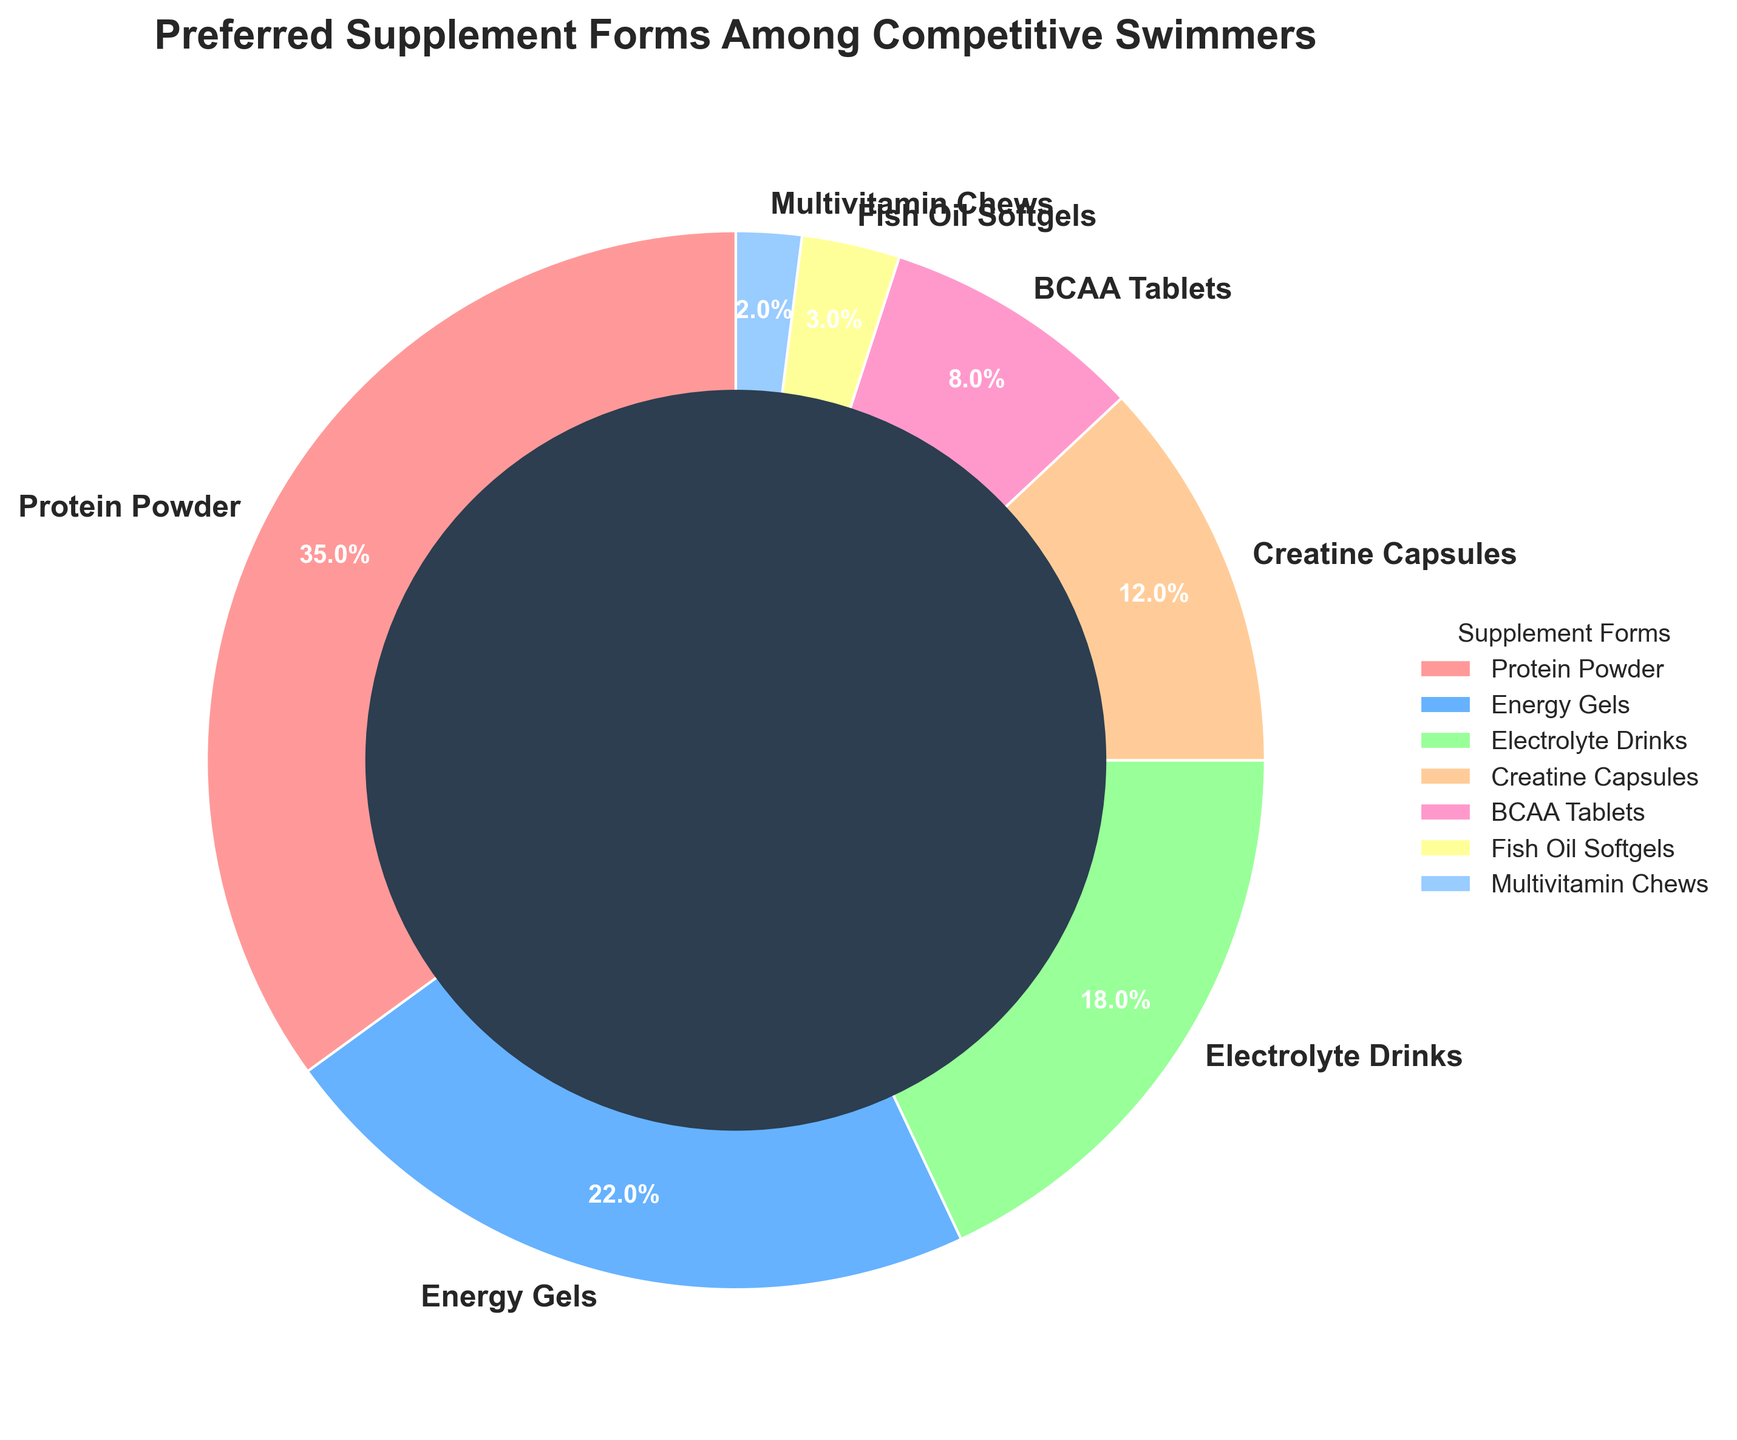What percentage of swimmers prefer Protein Powder and Energy Gels combined? To find the combined percentage for Protein Powder and Energy Gels, add their individual percentages: 35% (Protein Powder) + 22% (Energy Gels) = 57%
Answer: 57% Which supplement form has the lowest preference among competitive swimmers? Look at the pie chart and identify the segment with the smallest percentage. Multivitamin Chews are shown as the smallest segment with 2%
Answer: Multivitamin Chews Is the percentage of swimmers who prefer Electrolyte Drinks more than those who prefer Creatine Capsules and Fish Oil Softgels combined? Sum the percentages of Creatine Capsules and Fish Oil Softgels: 12% + 3% = 15%. Compare this with the percentage of Electrolyte Drinks, which is 18%. Since 18% > 15%, the answer is yes
Answer: Yes By how much does the preference for Protein Powder exceed the preference for BCAA Tablets? Subtract the percentage of BCAA Tablets from that of Protein Powder: 35% - 8% = 27%
Answer: 27% Which two supplement forms have a combined preference close to that of Protein Powder alone? Examine the percentages of other supplement forms to find two that sum to approximately 35%. Creatine Capsules (12%) and Electrolyte Drinks (18%) combined give: 12% + 18% = 30%, which is close to 35%
Answer: Creatine Capsules and Electrolyte Drinks If you sum the preferences of BCAA Tablets, Fish Oil Softgels, and Multivitamin Chews, what percentage do you get? Add the percentages of BCAA Tablets, Fish Oil Softgels, and Multivitamin Chews: 8% + 3% + 2% = 13%
Answer: 13% Which color represents the most preferred supplement form? Identify the color of the segment corresponding to the supplement form with the highest percentage. The wedge for Protein Powder, representing 35%, is colored in a specific visual color code, e.g., red
Answer: Red Which supplement form is preferred by 12% of competitive swimmers, and what's its color? Look at the segment showing 12% and note the label and color. Creatine Capsules correspond to 12% and are represented by their associated color
Answer: Creatine Capsules Compare the preferences for Fish Oil Softgels and Multivitamin Chews. Which one is higher and by how much? Subtract the percentage of Multivitamin Chews from that of Fish Oil Softgels: 3% - 2% = 1%
Answer: Fish Oil Softgels by 1% 